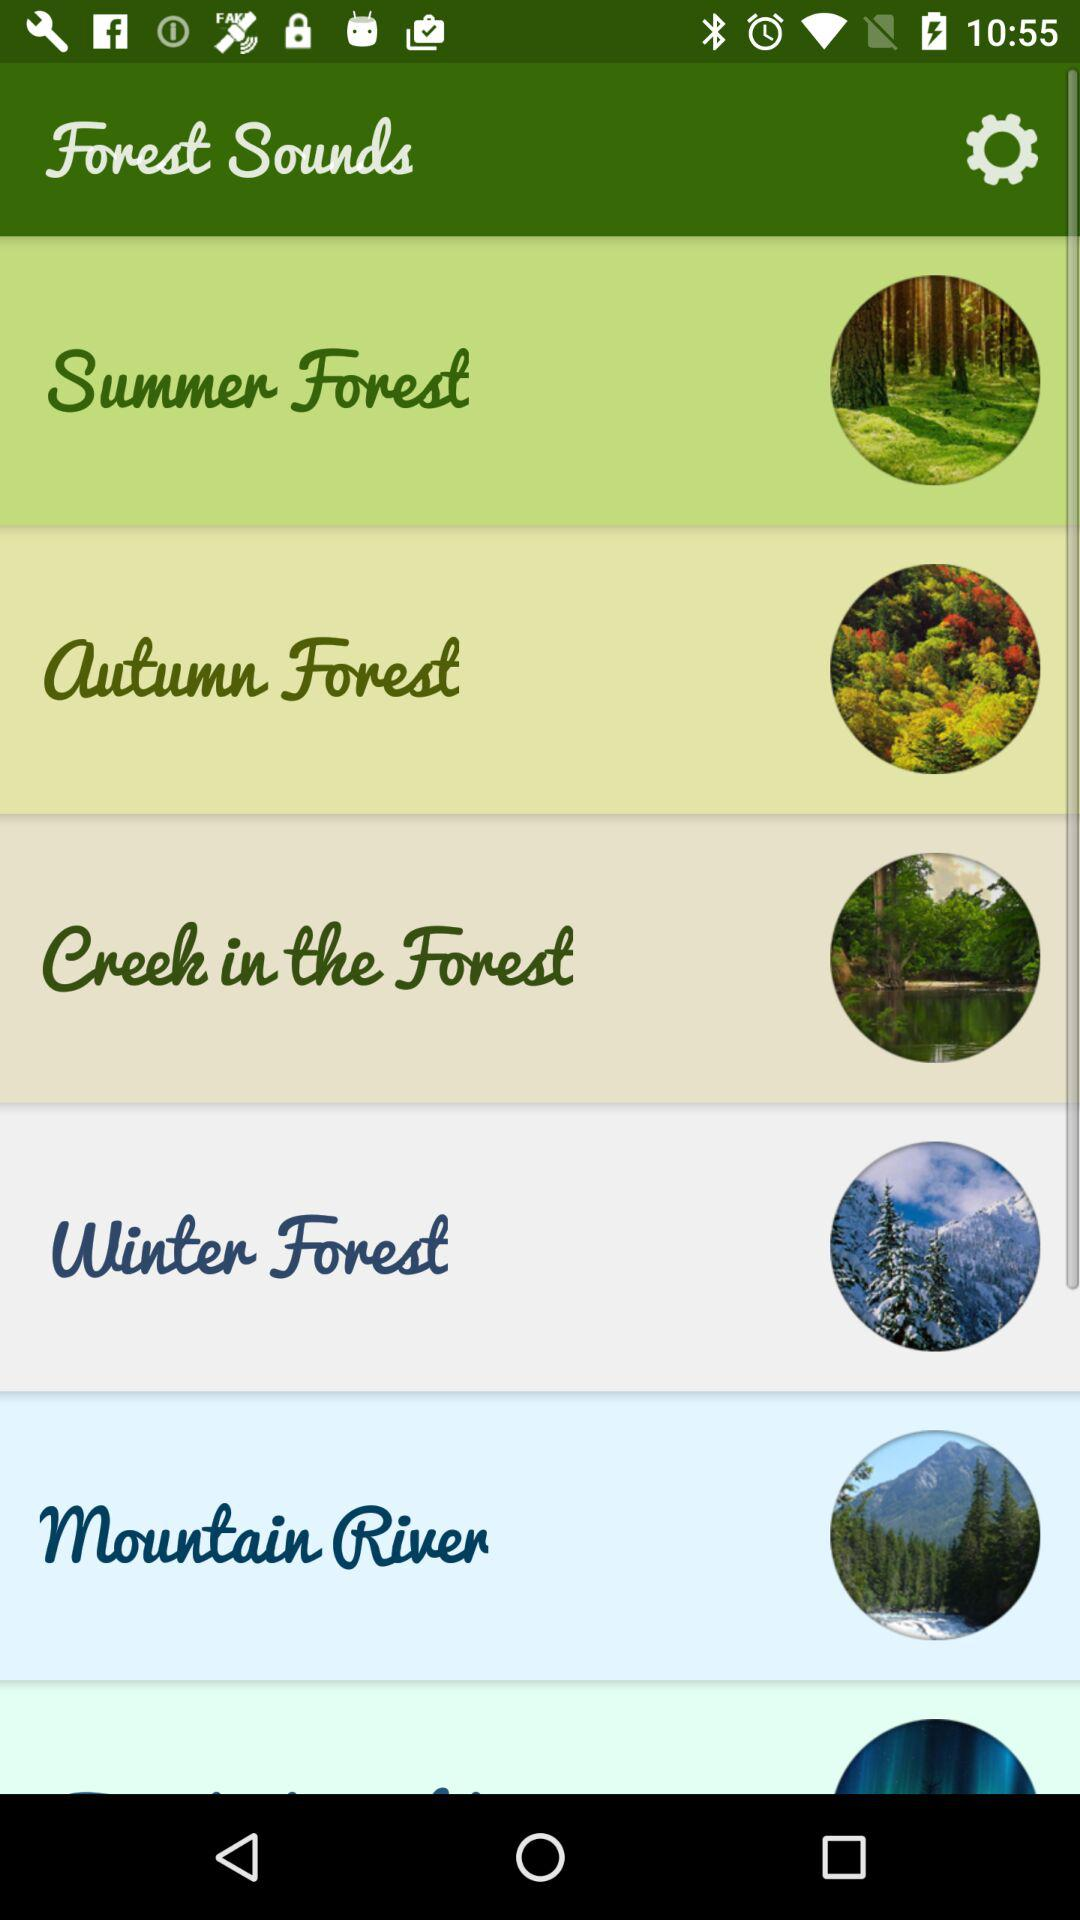Which option is selected?
When the provided information is insufficient, respond with <no answer>. <no answer> 